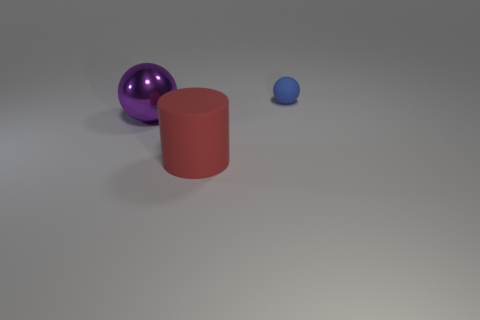There is a ball that is made of the same material as the red cylinder; what color is it?
Your response must be concise. Blue. What is the material of the sphere that is left of the blue rubber sphere?
Offer a very short reply. Metal. Is the shape of the blue rubber thing the same as the object that is on the left side of the red thing?
Your response must be concise. Yes. The thing that is both to the right of the big purple sphere and behind the large rubber thing is made of what material?
Ensure brevity in your answer.  Rubber. There is a matte thing that is the same size as the purple metal object; what color is it?
Make the answer very short. Red. Does the blue object have the same material as the large object that is left of the red matte object?
Offer a very short reply. No. How many other things are the same size as the purple object?
Give a very brief answer. 1. Is there a purple thing that is in front of the rubber thing that is in front of the sphere that is to the right of the big purple thing?
Your answer should be compact. No. What size is the blue rubber sphere?
Your response must be concise. Small. What size is the rubber cylinder that is in front of the big purple shiny object?
Offer a terse response. Large. 